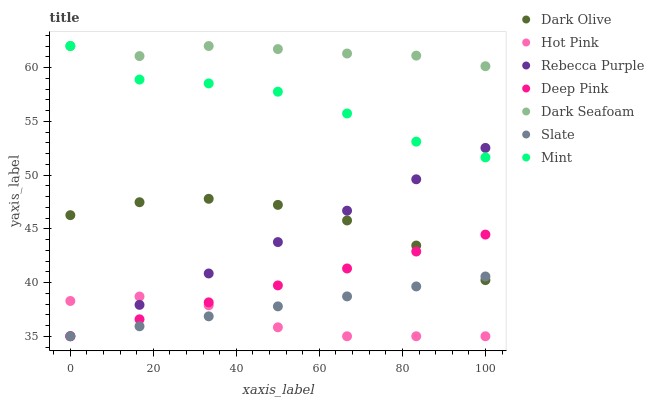Does Hot Pink have the minimum area under the curve?
Answer yes or no. Yes. Does Dark Seafoam have the maximum area under the curve?
Answer yes or no. Yes. Does Slate have the minimum area under the curve?
Answer yes or no. No. Does Slate have the maximum area under the curve?
Answer yes or no. No. Is Deep Pink the smoothest?
Answer yes or no. Yes. Is Mint the roughest?
Answer yes or no. Yes. Is Slate the smoothest?
Answer yes or no. No. Is Slate the roughest?
Answer yes or no. No. Does Deep Pink have the lowest value?
Answer yes or no. Yes. Does Dark Olive have the lowest value?
Answer yes or no. No. Does Mint have the highest value?
Answer yes or no. Yes. Does Slate have the highest value?
Answer yes or no. No. Is Rebecca Purple less than Dark Seafoam?
Answer yes or no. Yes. Is Mint greater than Slate?
Answer yes or no. Yes. Does Rebecca Purple intersect Slate?
Answer yes or no. Yes. Is Rebecca Purple less than Slate?
Answer yes or no. No. Is Rebecca Purple greater than Slate?
Answer yes or no. No. Does Rebecca Purple intersect Dark Seafoam?
Answer yes or no. No. 